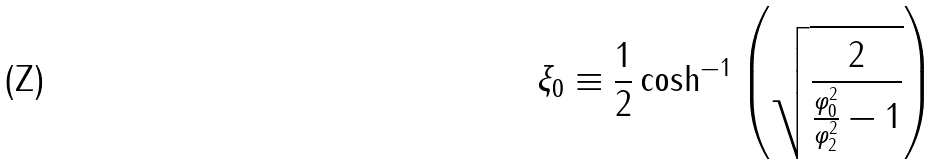Convert formula to latex. <formula><loc_0><loc_0><loc_500><loc_500>\xi _ { 0 } \equiv \frac { 1 } { 2 } \cosh ^ { - 1 } \left ( \sqrt { \frac { 2 } { \frac { \varphi _ { 0 } ^ { 2 } } { \varphi _ { 2 } ^ { 2 } } - 1 } } \right )</formula> 